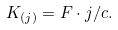Convert formula to latex. <formula><loc_0><loc_0><loc_500><loc_500>K _ { ( j ) } = F \cdot j / c .</formula> 